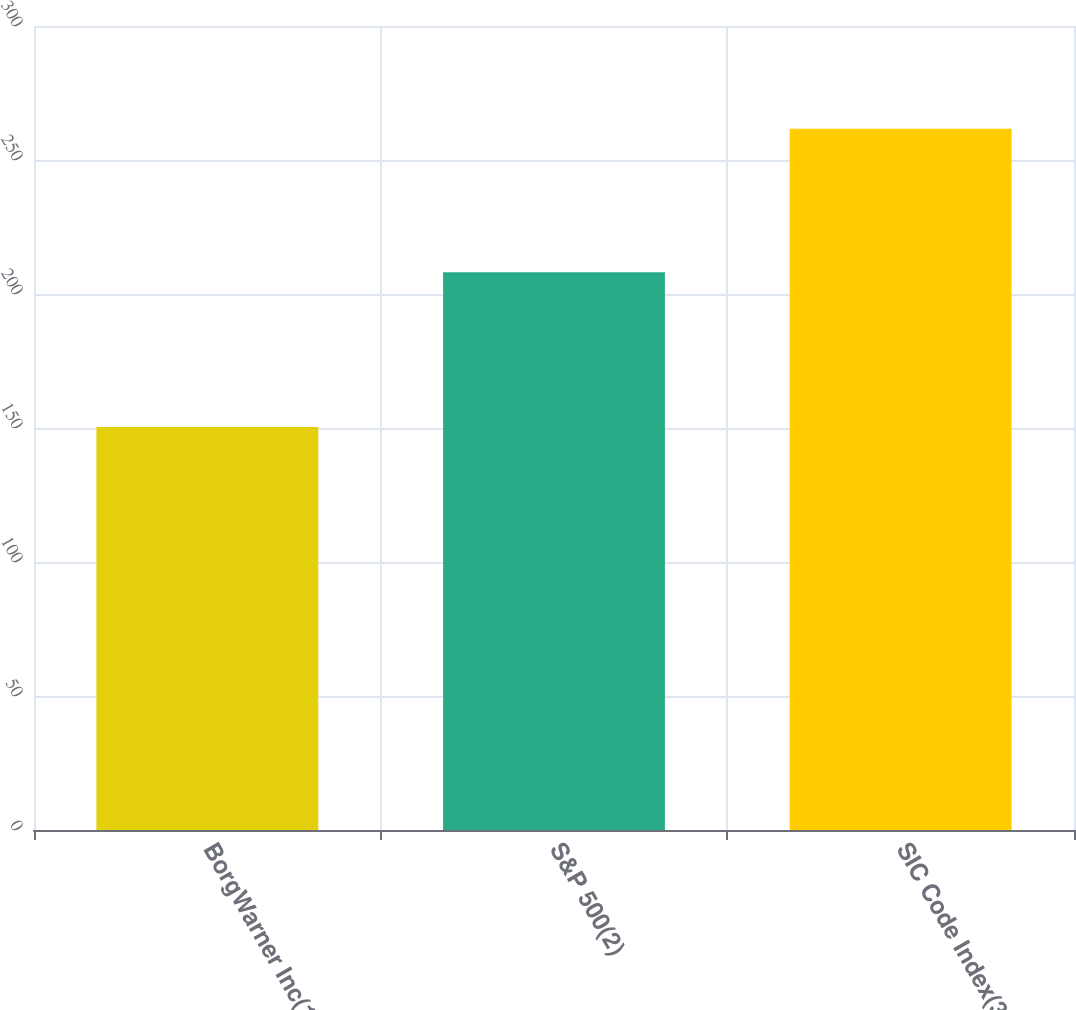Convert chart to OTSL. <chart><loc_0><loc_0><loc_500><loc_500><bar_chart><fcel>BorgWarner Inc(1)<fcel>S&P 500(2)<fcel>SIC Code Index(3)<nl><fcel>150.33<fcel>208.14<fcel>261.64<nl></chart> 